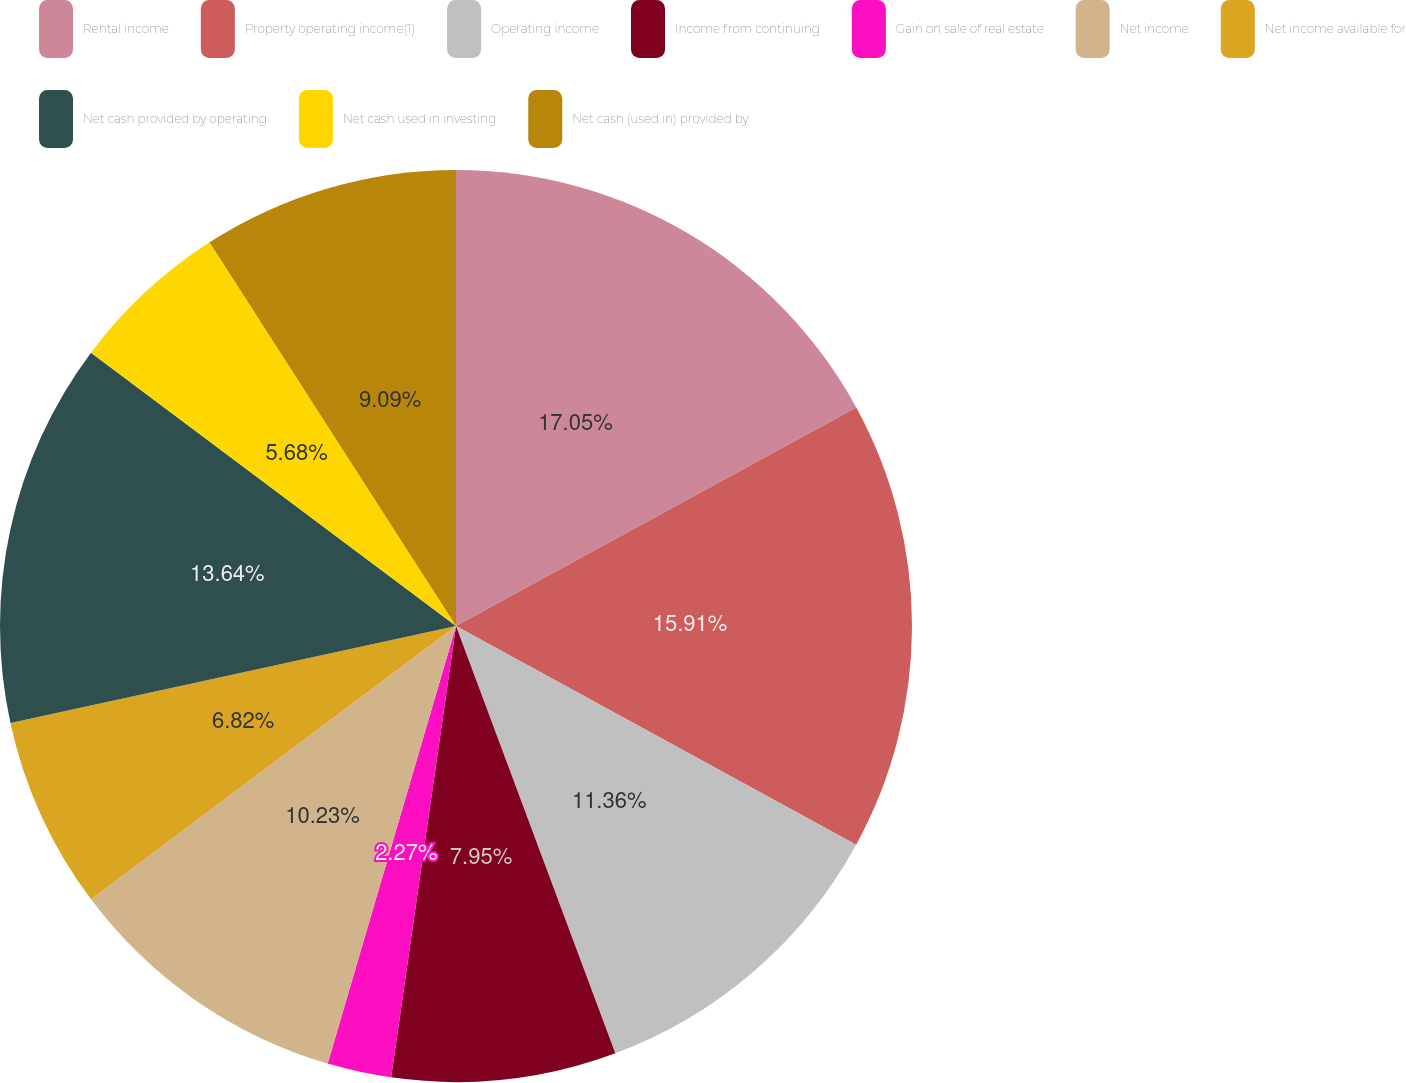Convert chart. <chart><loc_0><loc_0><loc_500><loc_500><pie_chart><fcel>Rental income<fcel>Property operating income(1)<fcel>Operating income<fcel>Income from continuing<fcel>Gain on sale of real estate<fcel>Net income<fcel>Net income available for<fcel>Net cash provided by operating<fcel>Net cash used in investing<fcel>Net cash (used in) provided by<nl><fcel>17.05%<fcel>15.91%<fcel>11.36%<fcel>7.95%<fcel>2.27%<fcel>10.23%<fcel>6.82%<fcel>13.64%<fcel>5.68%<fcel>9.09%<nl></chart> 